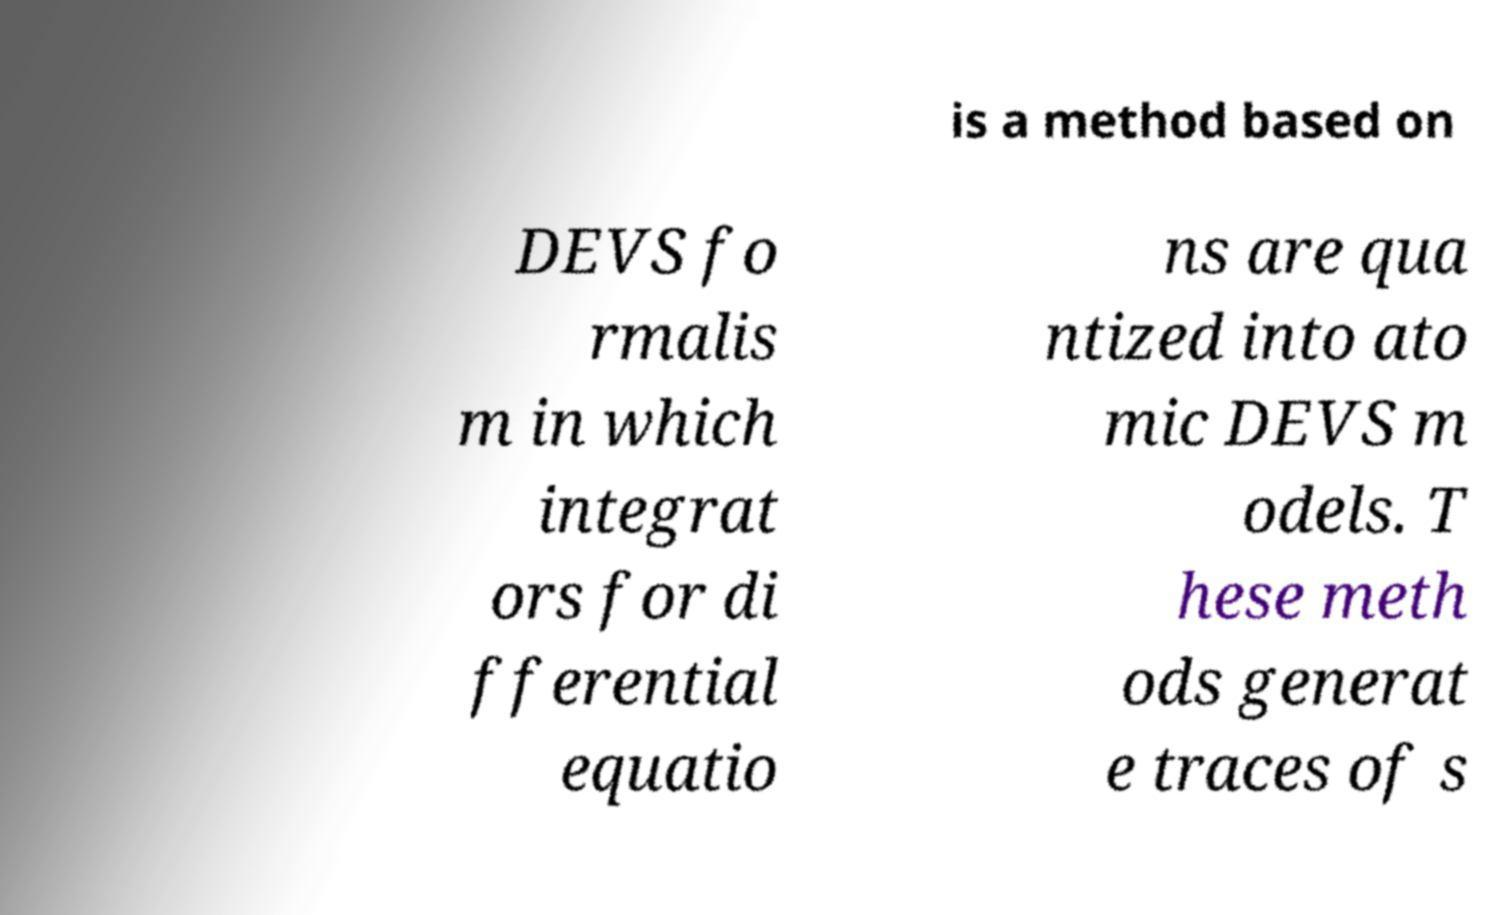I need the written content from this picture converted into text. Can you do that? is a method based on DEVS fo rmalis m in which integrat ors for di fferential equatio ns are qua ntized into ato mic DEVS m odels. T hese meth ods generat e traces of s 